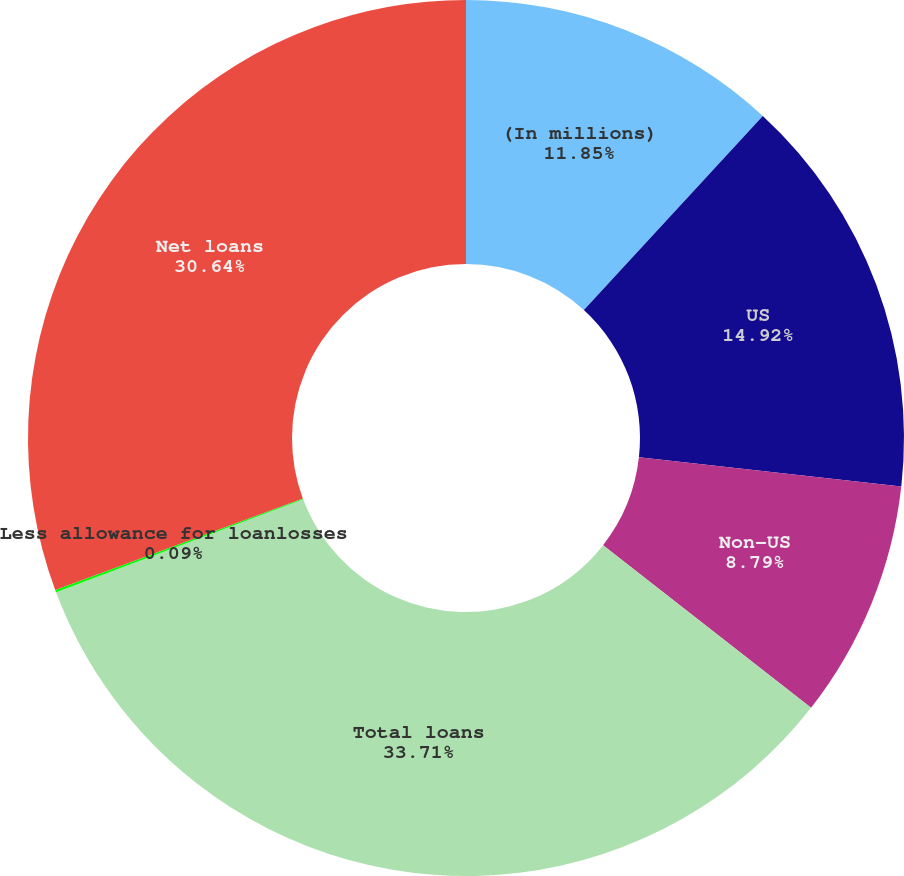Convert chart to OTSL. <chart><loc_0><loc_0><loc_500><loc_500><pie_chart><fcel>(In millions)<fcel>US<fcel>Non-US<fcel>Total loans<fcel>Less allowance for loanlosses<fcel>Net loans<nl><fcel>11.85%<fcel>14.92%<fcel>8.79%<fcel>33.71%<fcel>0.09%<fcel>30.64%<nl></chart> 